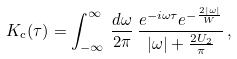<formula> <loc_0><loc_0><loc_500><loc_500>K _ { \text {c} } ( \tau ) = \int _ { - \infty } ^ { \infty } \, \frac { d \omega } { 2 \pi } \, \frac { e ^ { - i \omega \tau } e ^ { - \frac { 2 | \omega | } { W } } } { | \omega | + \frac { 2 U _ { 2 } } { \pi } } \, ,</formula> 